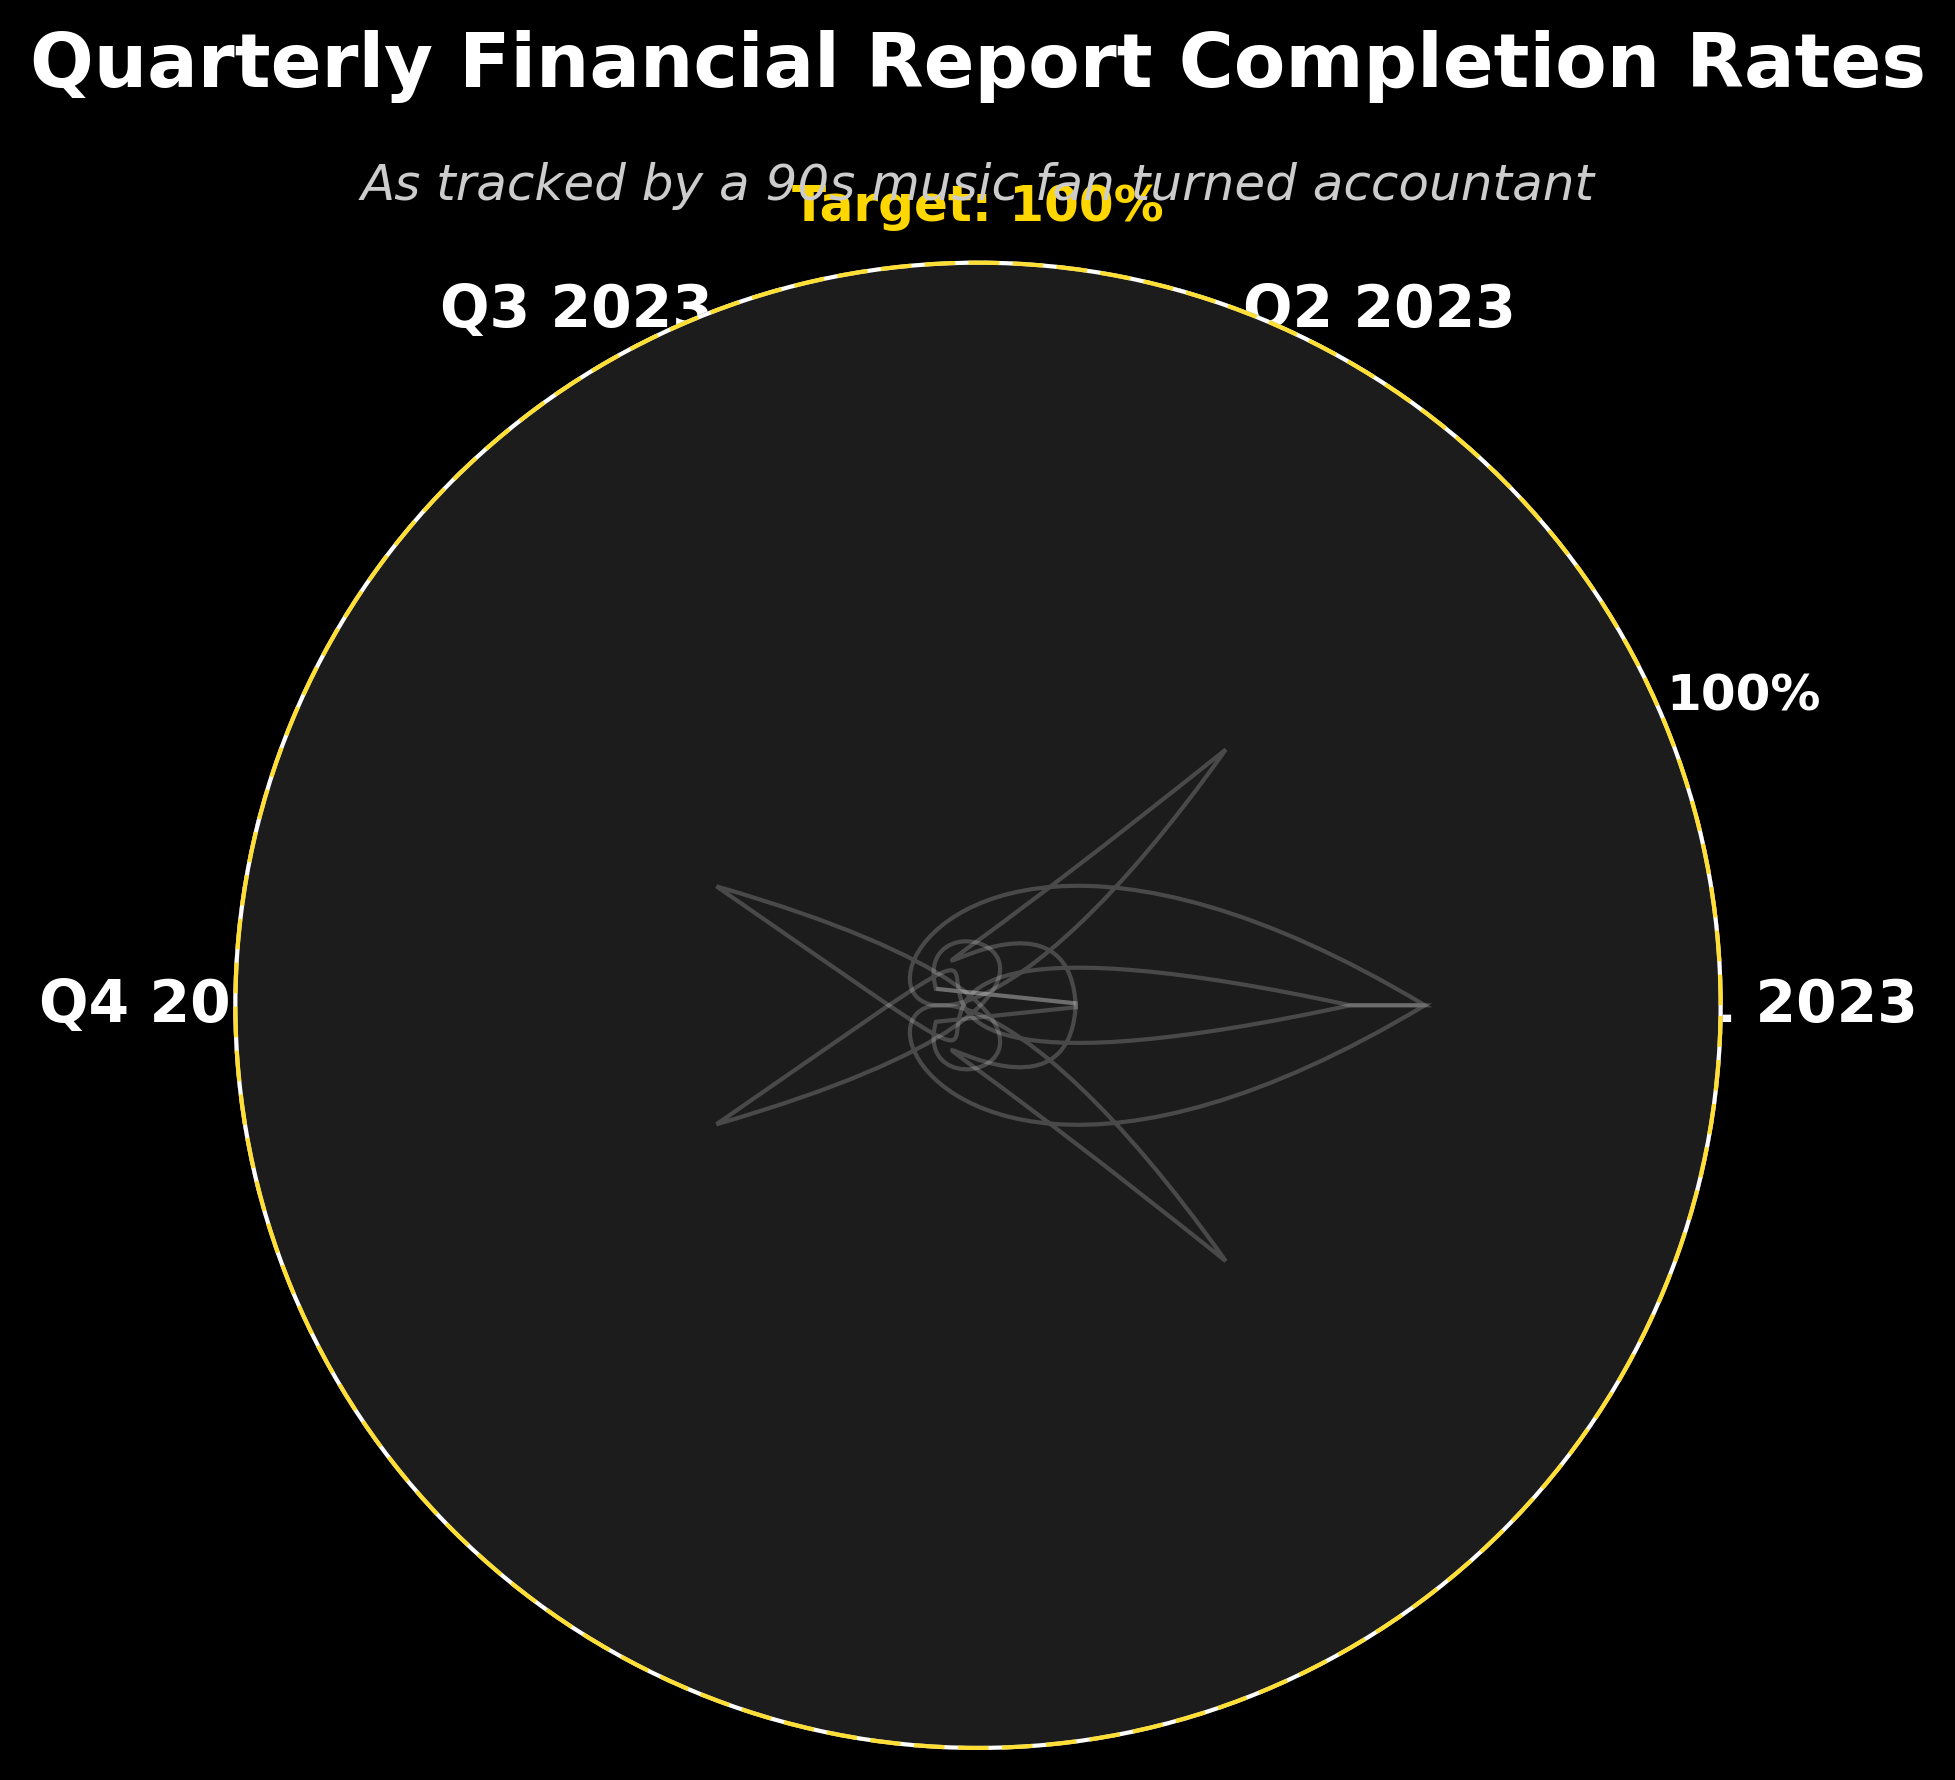What are the quarterly financial report completion rates for 2023? The completion rates are depicted on the gauge chart from Q1 to Q4, with distinct colored bars for each quarter.
Answer: 92%, 88%, 95%, 85% What is the target completion rate marked on the chart? The target completion rate is shown by a dashed line and labeled text near the top of the gauge.
Answer: 100% Which quarter had the highest completion rate? By comparing the heights of the bars for each quarter, Q3 2023 has the highest bar.
Answer: Q3 2023 What is the difference in completion rate between Q1 and Q4? Subtract the completion rate of Q4 (85%) from Q1 (92%).
Answer: 7% What is the average completion rate across all quarters? Sum up the completion rates of Q1, Q2, Q3, and Q4 and divide by 4: (92 + 88 + 95 + 85) / 4.
Answer: 90% Is any quarter's completion rate as high as or higher than the target? Compare each quarter’s completion rate (< 100%) to the target (100%); none meet or exceed the target.
Answer: No Which quarter showed the largest drop in completion rate compared to the previous quarter? Calculate the difference between consecutive quarters: Q2-Q1 (92-88=4), Q3-Q2 (95-88=7), Q4-Q3 (95-85=10). Q4 shows the largest drop.
Answer: Q4 2023 How close was Q3 2023 to meeting the target completion rate? Subtract Q3's completion rate (95%) from the target (100%).
Answer: 5% How many distinct colors are used to represent the quarterly completion rates in the chart? The chart uses distinct colors for each quarter which include red, teal, cyan, and salmon.
Answer: 4 What percentage of the total completion rate for all quarters does Q2 2023 represent? First, calculate the total completion rate for all quarters: (92 + 88 + 95 + 85) = 360. Then, determine the percentage represented by Q2: (88 / 360) * 100.
Answer: 24.44% 